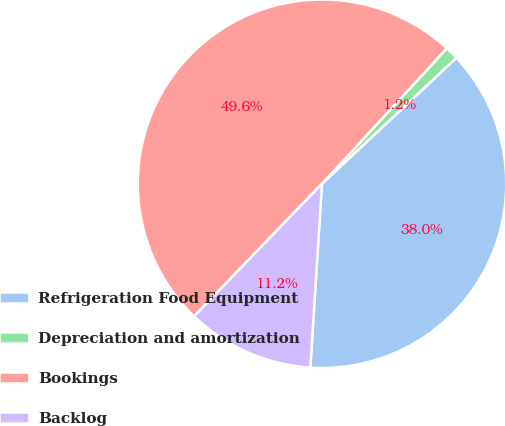Convert chart. <chart><loc_0><loc_0><loc_500><loc_500><pie_chart><fcel>Refrigeration Food Equipment<fcel>Depreciation and amortization<fcel>Bookings<fcel>Backlog<nl><fcel>38.0%<fcel>1.16%<fcel>49.64%<fcel>11.2%<nl></chart> 